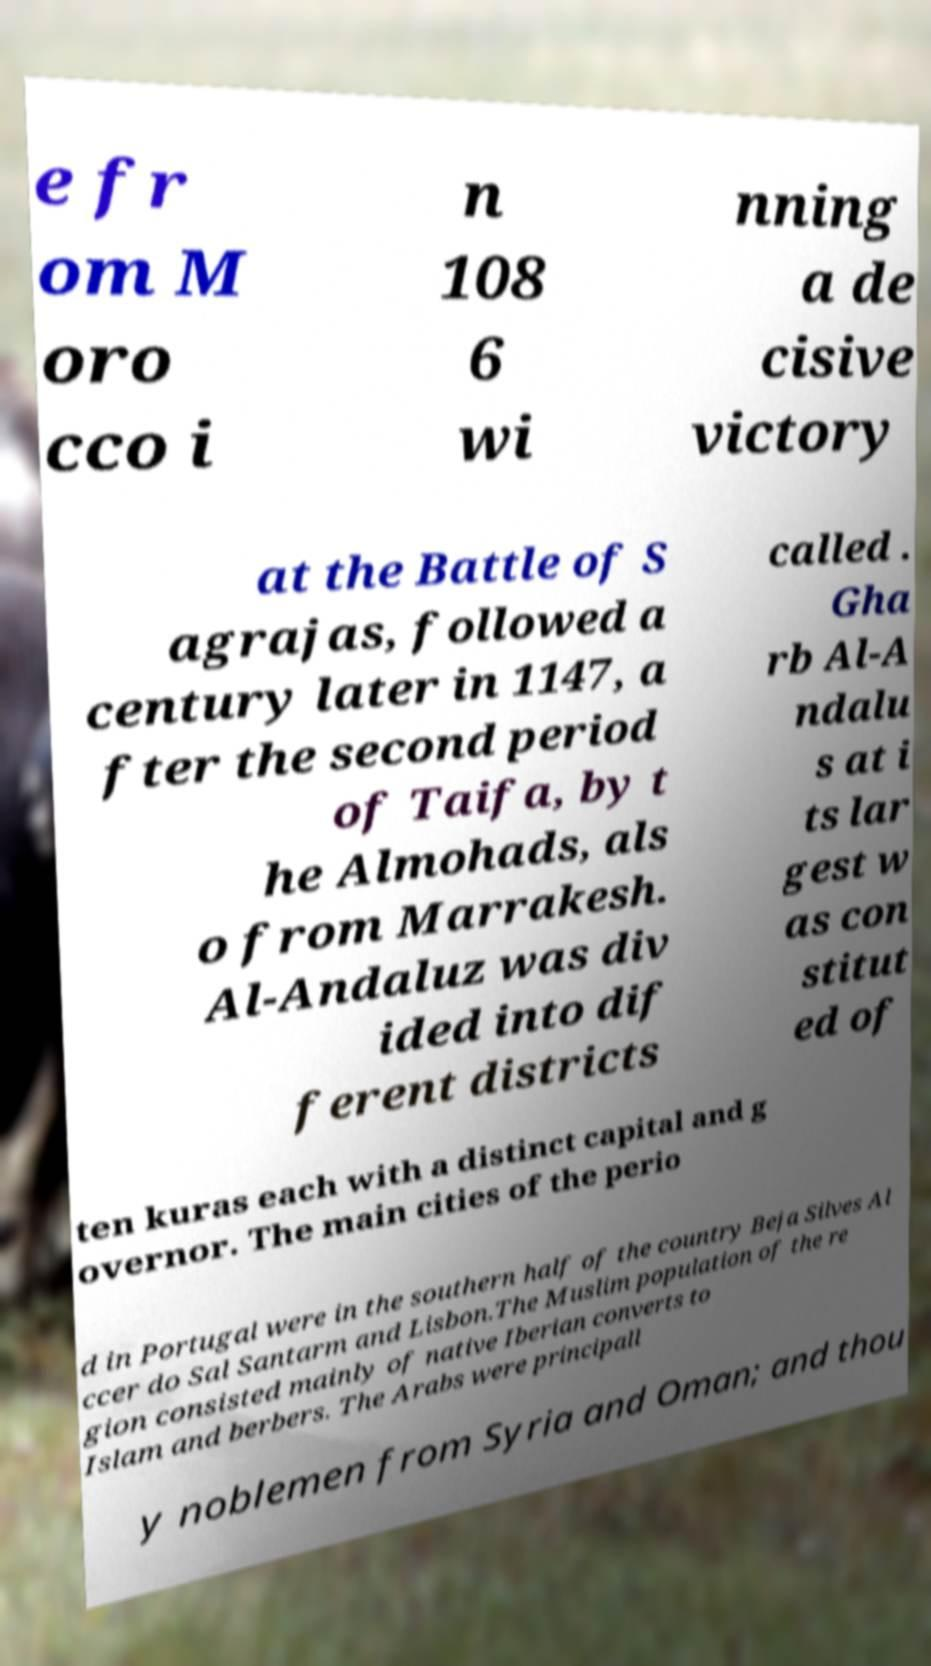I need the written content from this picture converted into text. Can you do that? e fr om M oro cco i n 108 6 wi nning a de cisive victory at the Battle of S agrajas, followed a century later in 1147, a fter the second period of Taifa, by t he Almohads, als o from Marrakesh. Al-Andaluz was div ided into dif ferent districts called . Gha rb Al-A ndalu s at i ts lar gest w as con stitut ed of ten kuras each with a distinct capital and g overnor. The main cities of the perio d in Portugal were in the southern half of the country Beja Silves Al ccer do Sal Santarm and Lisbon.The Muslim population of the re gion consisted mainly of native Iberian converts to Islam and berbers. The Arabs were principall y noblemen from Syria and Oman; and thou 